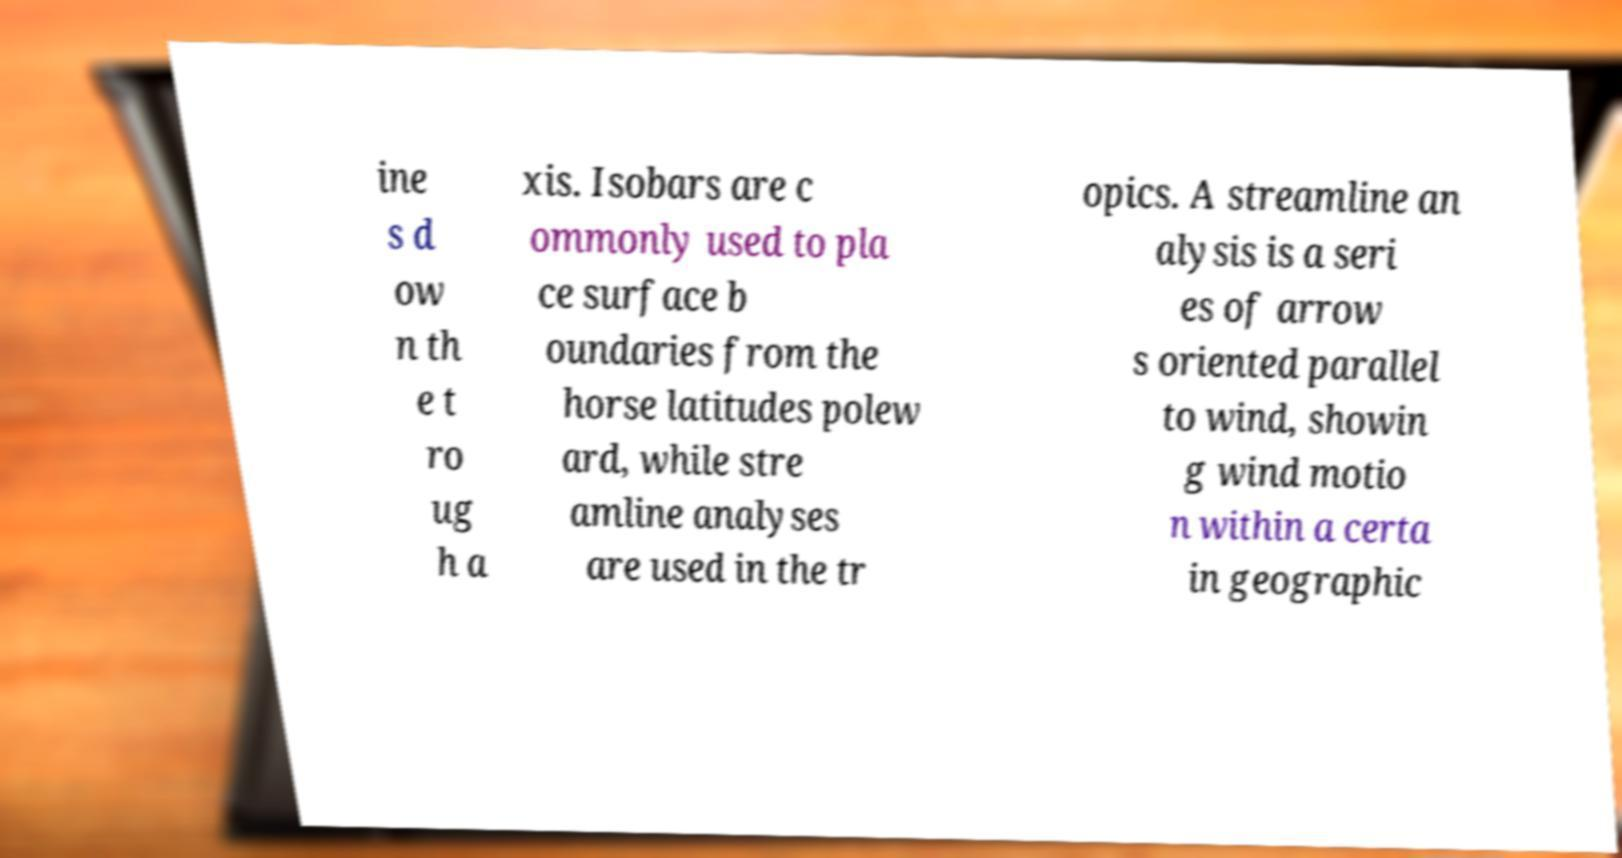There's text embedded in this image that I need extracted. Can you transcribe it verbatim? ine s d ow n th e t ro ug h a xis. Isobars are c ommonly used to pla ce surface b oundaries from the horse latitudes polew ard, while stre amline analyses are used in the tr opics. A streamline an alysis is a seri es of arrow s oriented parallel to wind, showin g wind motio n within a certa in geographic 